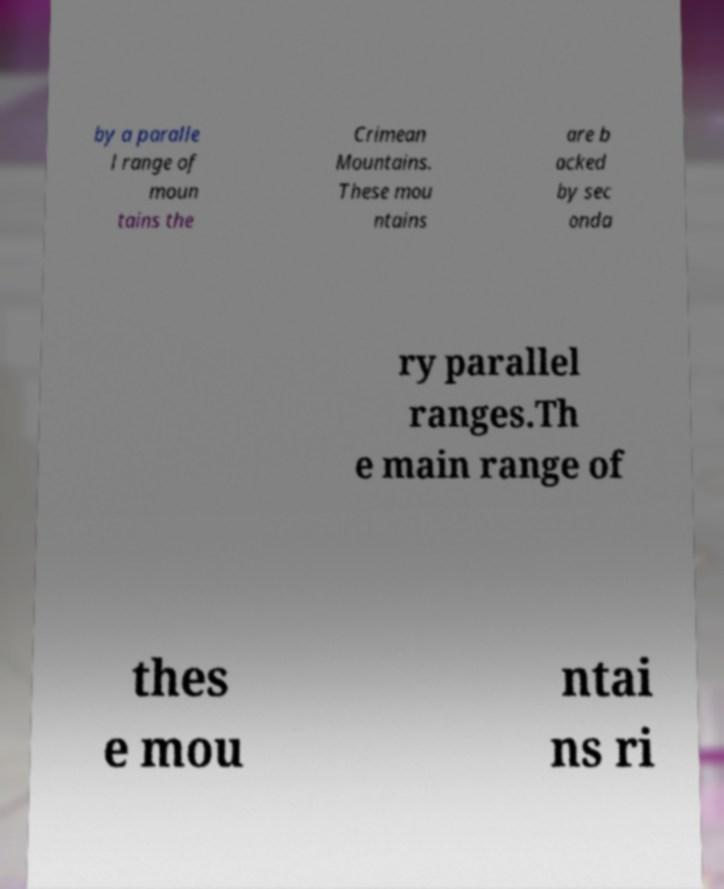There's text embedded in this image that I need extracted. Can you transcribe it verbatim? by a paralle l range of moun tains the Crimean Mountains. These mou ntains are b acked by sec onda ry parallel ranges.Th e main range of thes e mou ntai ns ri 